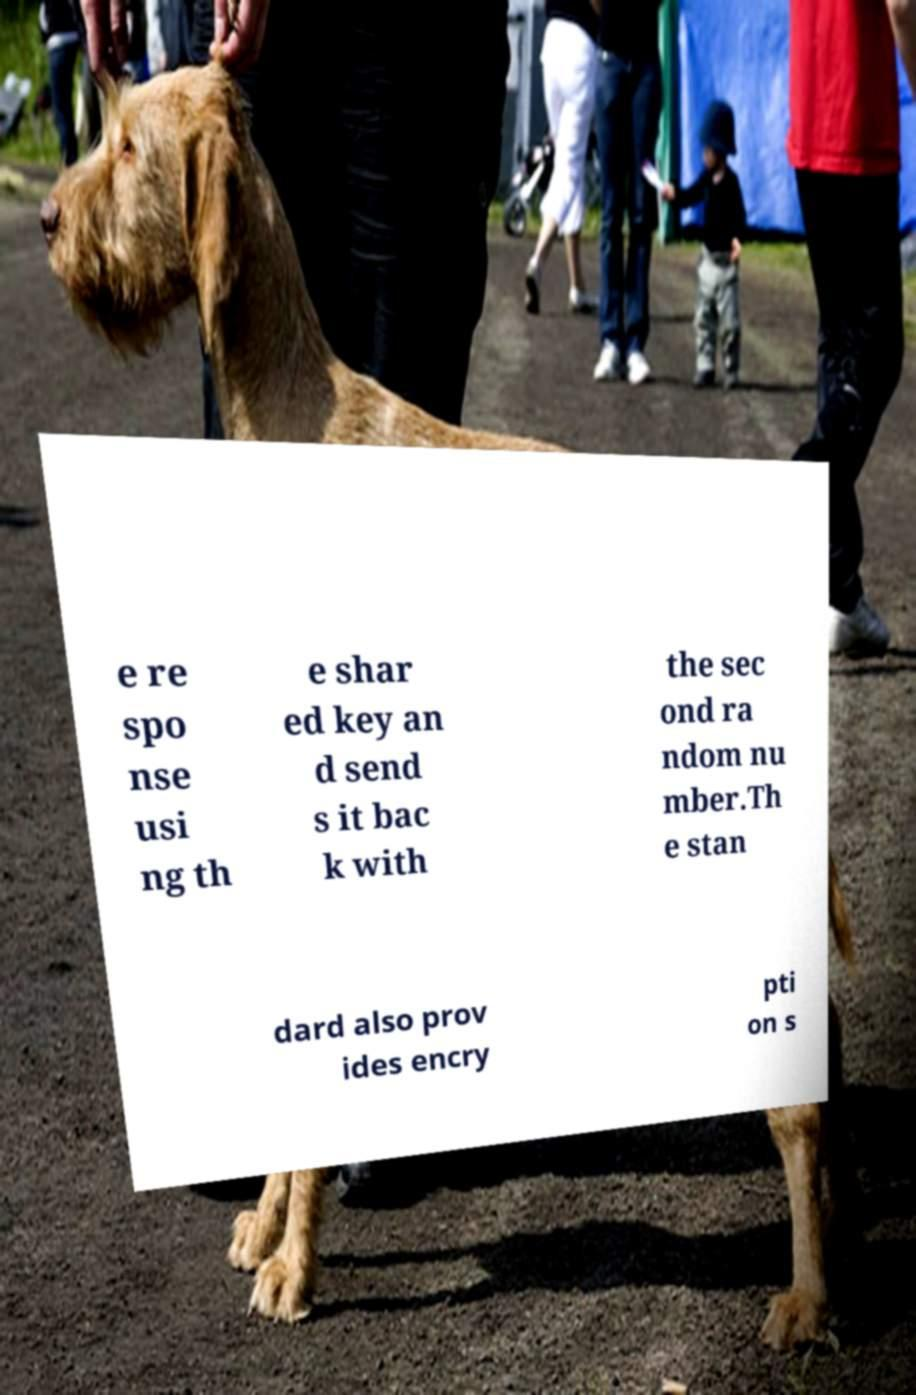Please identify and transcribe the text found in this image. e re spo nse usi ng th e shar ed key an d send s it bac k with the sec ond ra ndom nu mber.Th e stan dard also prov ides encry pti on s 